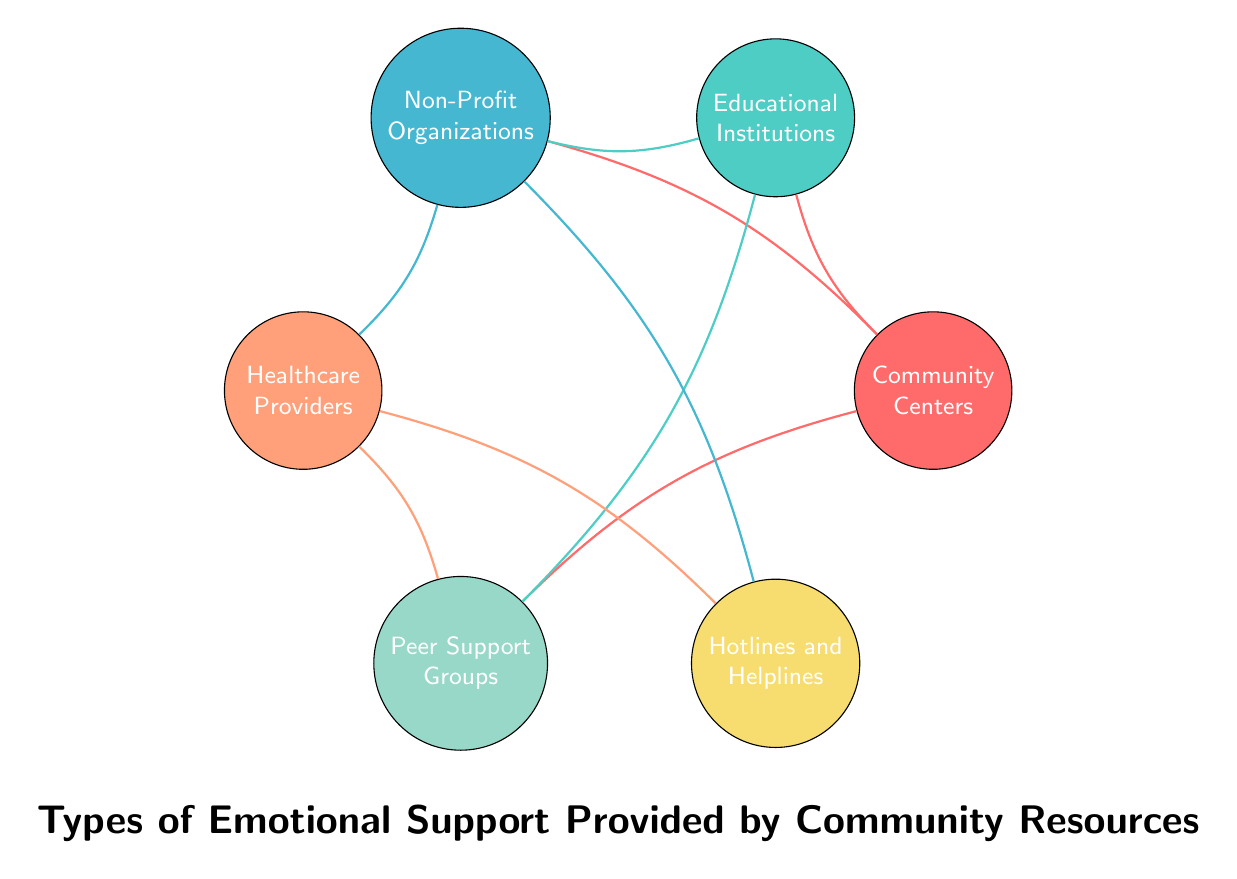What are the total nodes in the diagram? The diagram shows a list of six community resources, which are represented as nodes. These resources are Community Centers, Educational Institutions, Non-Profit Organizations, Healthcare Providers, Peer Support Groups, and Hotlines and Helplines. Counting these gives a total of six nodes.
Answer: 6 Which two nodes are directly connected to Community Centers? By examining the connections emanating from Community Centers, we see that it has direct links to Educational Institutions, Non-Profit Organizations, and Peer Support Groups. Therefore, all three nodes are directly connected; however, the question requires only two. The first two listed are sufficient to answer.
Answer: Educational Institutions, Non-Profit Organizations How many connections does Non-Profit Organizations have? To determine the number of connections from Non-Profit Organizations, we need to look at the edges linked to it. It connects to Healthcare Providers and Hotlines and Helplines, totaling three connections (including links from other nodes). The specific direct connections are two.
Answer: 2 Which node is connected to both Healthcare Providers and Educational Institutions? By looking at the connections, we find that Peer Support Groups is the only node that has direct links to both Healthcare Providers and Educational Institutions. Therefore, it satisfies the condition of being connected to both specific nodes.
Answer: Peer Support Groups What is the direct relationship between Healthcare Providers and Hotlines and Helplines? The relationship is a direct connection as both nodes are linked by a drawn edge in the diagram. This means that there is an established connection that indicates they share a support relationship or resource pathway.
Answer: Direct connection How many types of organizations are represented in the diagram with connections to Peer Support Groups? To find the answer, we look specifically for all the nodes that have an edge directly linking to Peer Support Groups. The nodes that connect to Peer Support Groups are Community Centers, Educational Institutions, and Healthcare Providers. Thus, there are three different types of organizations connected to Peer Support Groups.
Answer: 3 Which node is indirectly connected to Hotlines and Helplines through Non-Profit Organizations? The indirect connection works by following the links: Non-Profit Organizations connects directly to Healthcare Providers, which then connects back to Peer Support Groups. Hence, Peer Support Groups is indirectly connected to Hotlines and Helplines via Non-Profit Organizations.
Answer: Peer Support Groups 